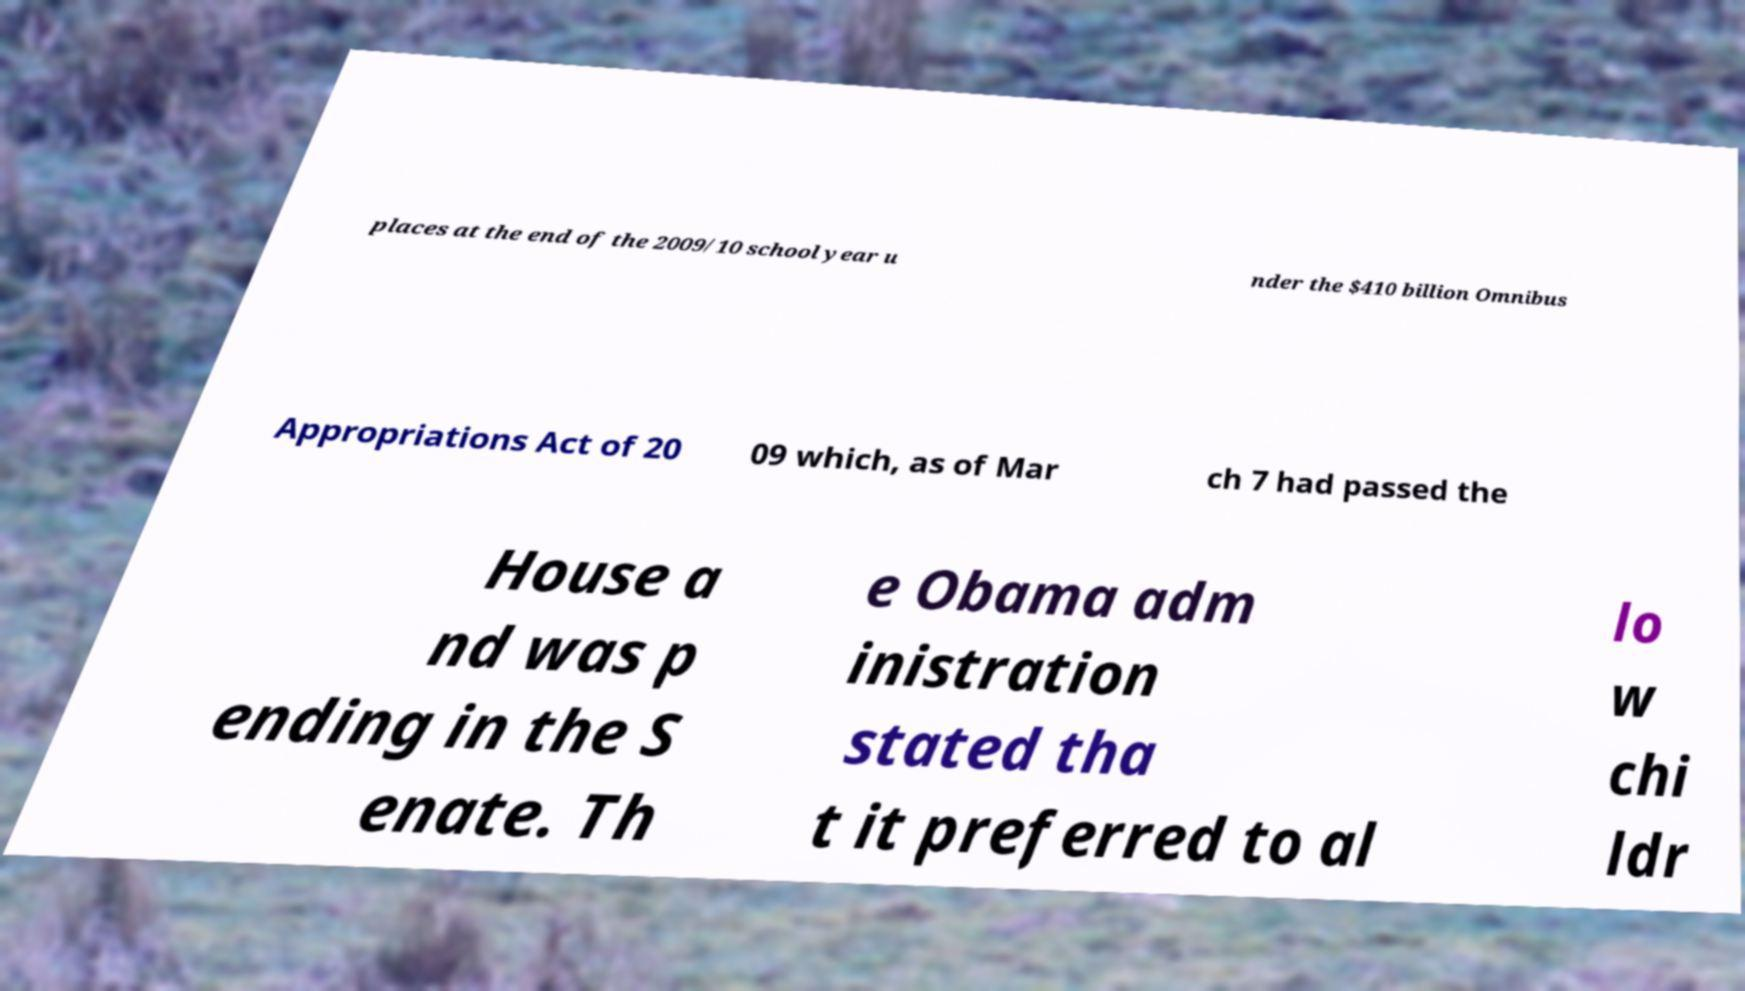What messages or text are displayed in this image? I need them in a readable, typed format. places at the end of the 2009/10 school year u nder the $410 billion Omnibus Appropriations Act of 20 09 which, as of Mar ch 7 had passed the House a nd was p ending in the S enate. Th e Obama adm inistration stated tha t it preferred to al lo w chi ldr 